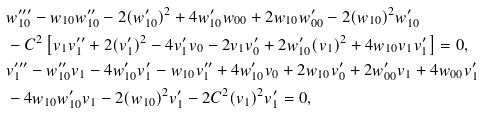Convert formula to latex. <formula><loc_0><loc_0><loc_500><loc_500>& w ^ { \prime \prime \prime } _ { 1 0 } - w _ { 1 0 } w ^ { \prime \prime } _ { 1 0 } - 2 ( w ^ { \prime } _ { 1 0 } ) ^ { 2 } + 4 w ^ { \prime } _ { 1 0 } w _ { 0 0 } + 2 w _ { 1 0 } w ^ { \prime } _ { 0 0 } - 2 ( w _ { 1 0 } ) ^ { 2 } w ^ { \prime } _ { 1 0 } \\ & - C ^ { 2 } \left [ v _ { 1 } v ^ { \prime \prime } _ { 1 } + 2 ( v ^ { \prime } _ { 1 } ) ^ { 2 } - 4 v ^ { \prime } _ { 1 } v _ { 0 } - 2 v _ { 1 } v ^ { \prime } _ { 0 } + 2 w ^ { \prime } _ { 1 0 } ( v _ { 1 } ) ^ { 2 } + 4 w _ { 1 0 } v _ { 1 } v ^ { \prime } _ { 1 } \right ] = 0 , \\ & v ^ { \prime \prime \prime } _ { 1 } - w ^ { \prime \prime } _ { 1 0 } v _ { 1 } - 4 w ^ { \prime } _ { 1 0 } v ^ { \prime } _ { 1 } - w _ { 1 0 } v ^ { \prime \prime } _ { 1 } + 4 w ^ { \prime } _ { 1 0 } v _ { 0 } + 2 w _ { 1 0 } v ^ { \prime } _ { 0 } + 2 w ^ { \prime } _ { 0 0 } v _ { 1 } + 4 w _ { 0 0 } v ^ { \prime } _ { 1 } \\ & - 4 w _ { 1 0 } w ^ { \prime } _ { 1 0 } v _ { 1 } - 2 ( w _ { 1 0 } ) ^ { 2 } v ^ { \prime } _ { 1 } - 2 C ^ { 2 } ( v _ { 1 } ) ^ { 2 } v ^ { \prime } _ { 1 } = 0 ,</formula> 